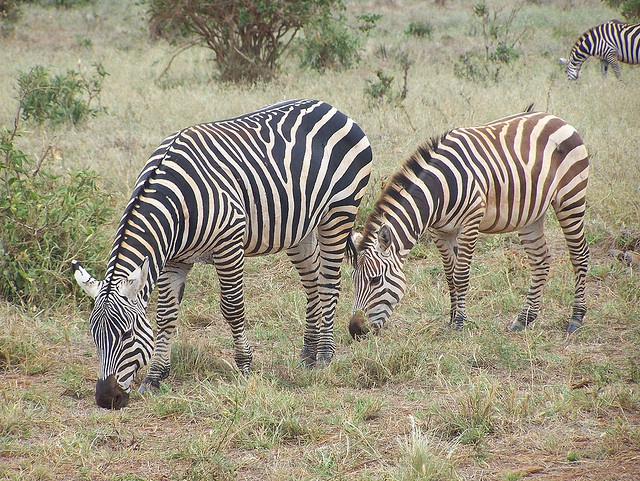Describe the objects in this image and their specific colors. I can see zebra in olive, gray, white, black, and darkgray tones, zebra in olive, gray, ivory, and darkgray tones, and zebra in olive, darkgray, gray, navy, and tan tones in this image. 